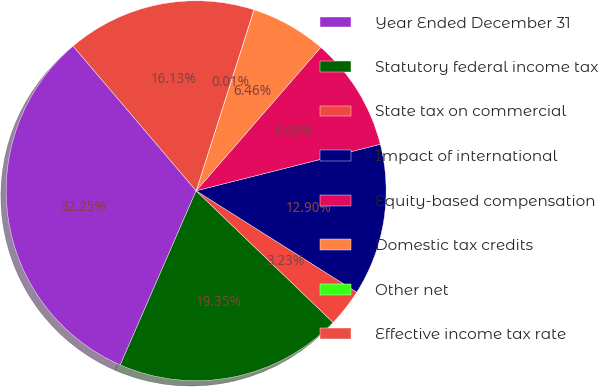<chart> <loc_0><loc_0><loc_500><loc_500><pie_chart><fcel>Year Ended December 31<fcel>Statutory federal income tax<fcel>State tax on commercial<fcel>Impact of international<fcel>Equity-based compensation<fcel>Domestic tax credits<fcel>Other net<fcel>Effective income tax rate<nl><fcel>32.25%<fcel>19.35%<fcel>3.23%<fcel>12.9%<fcel>9.68%<fcel>6.46%<fcel>0.01%<fcel>16.13%<nl></chart> 